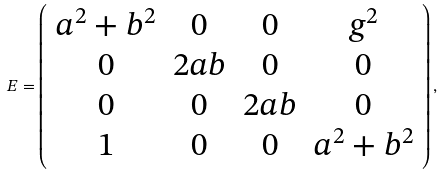<formula> <loc_0><loc_0><loc_500><loc_500>E = \left ( \begin{array} { c c c c } a ^ { 2 } + b ^ { 2 } & 0 & 0 & g ^ { 2 } \\ 0 & 2 a b & 0 & 0 \\ 0 & 0 & 2 a b & 0 \\ 1 & 0 & 0 & a ^ { 2 } + b ^ { 2 } \end{array} \right ) ,</formula> 